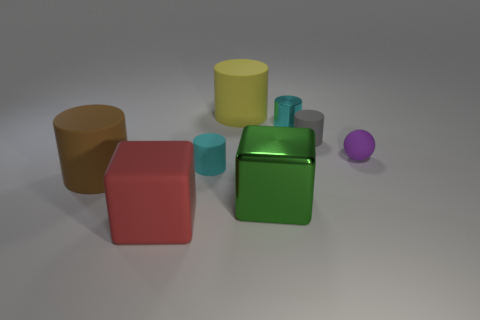Subtract all tiny shiny cylinders. How many cylinders are left? 4 Subtract all brown cylinders. How many cylinders are left? 4 Subtract all blue cylinders. Subtract all green balls. How many cylinders are left? 5 Add 1 small purple things. How many objects exist? 9 Subtract 0 green balls. How many objects are left? 8 Subtract all balls. How many objects are left? 7 Subtract all green things. Subtract all tiny spheres. How many objects are left? 6 Add 4 green shiny cubes. How many green shiny cubes are left? 5 Add 5 green balls. How many green balls exist? 5 